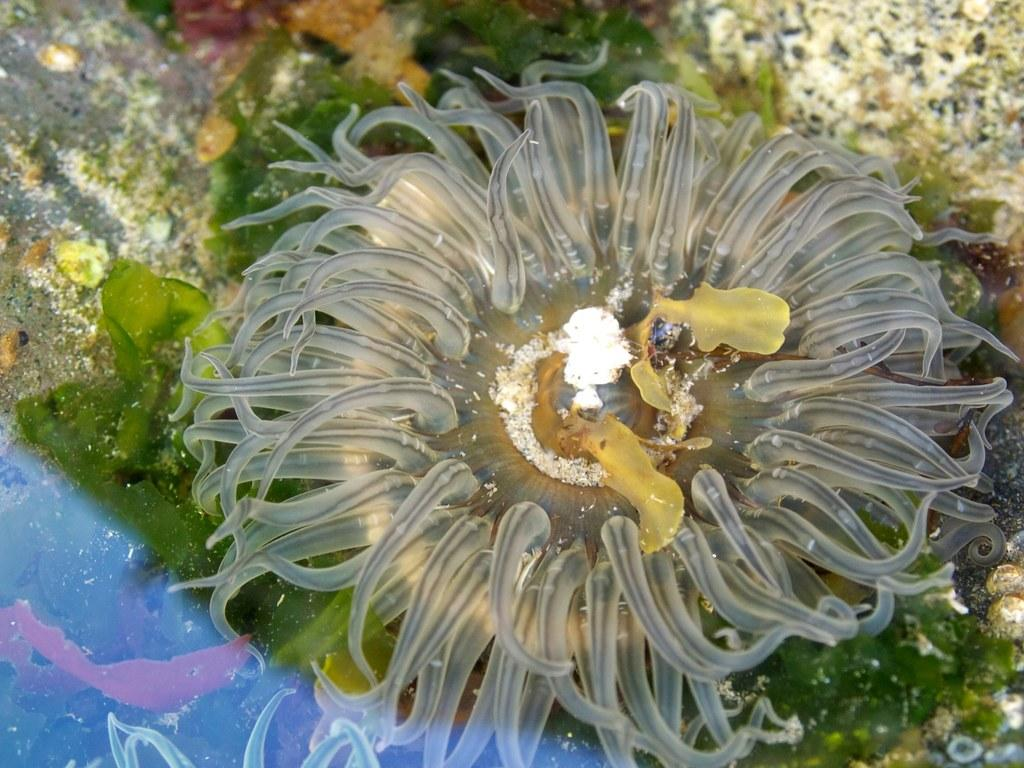Where is the maid standing with her rifle at the base in the image? There is no image provided, and therefore no maid, rifle, or base can be observed. 